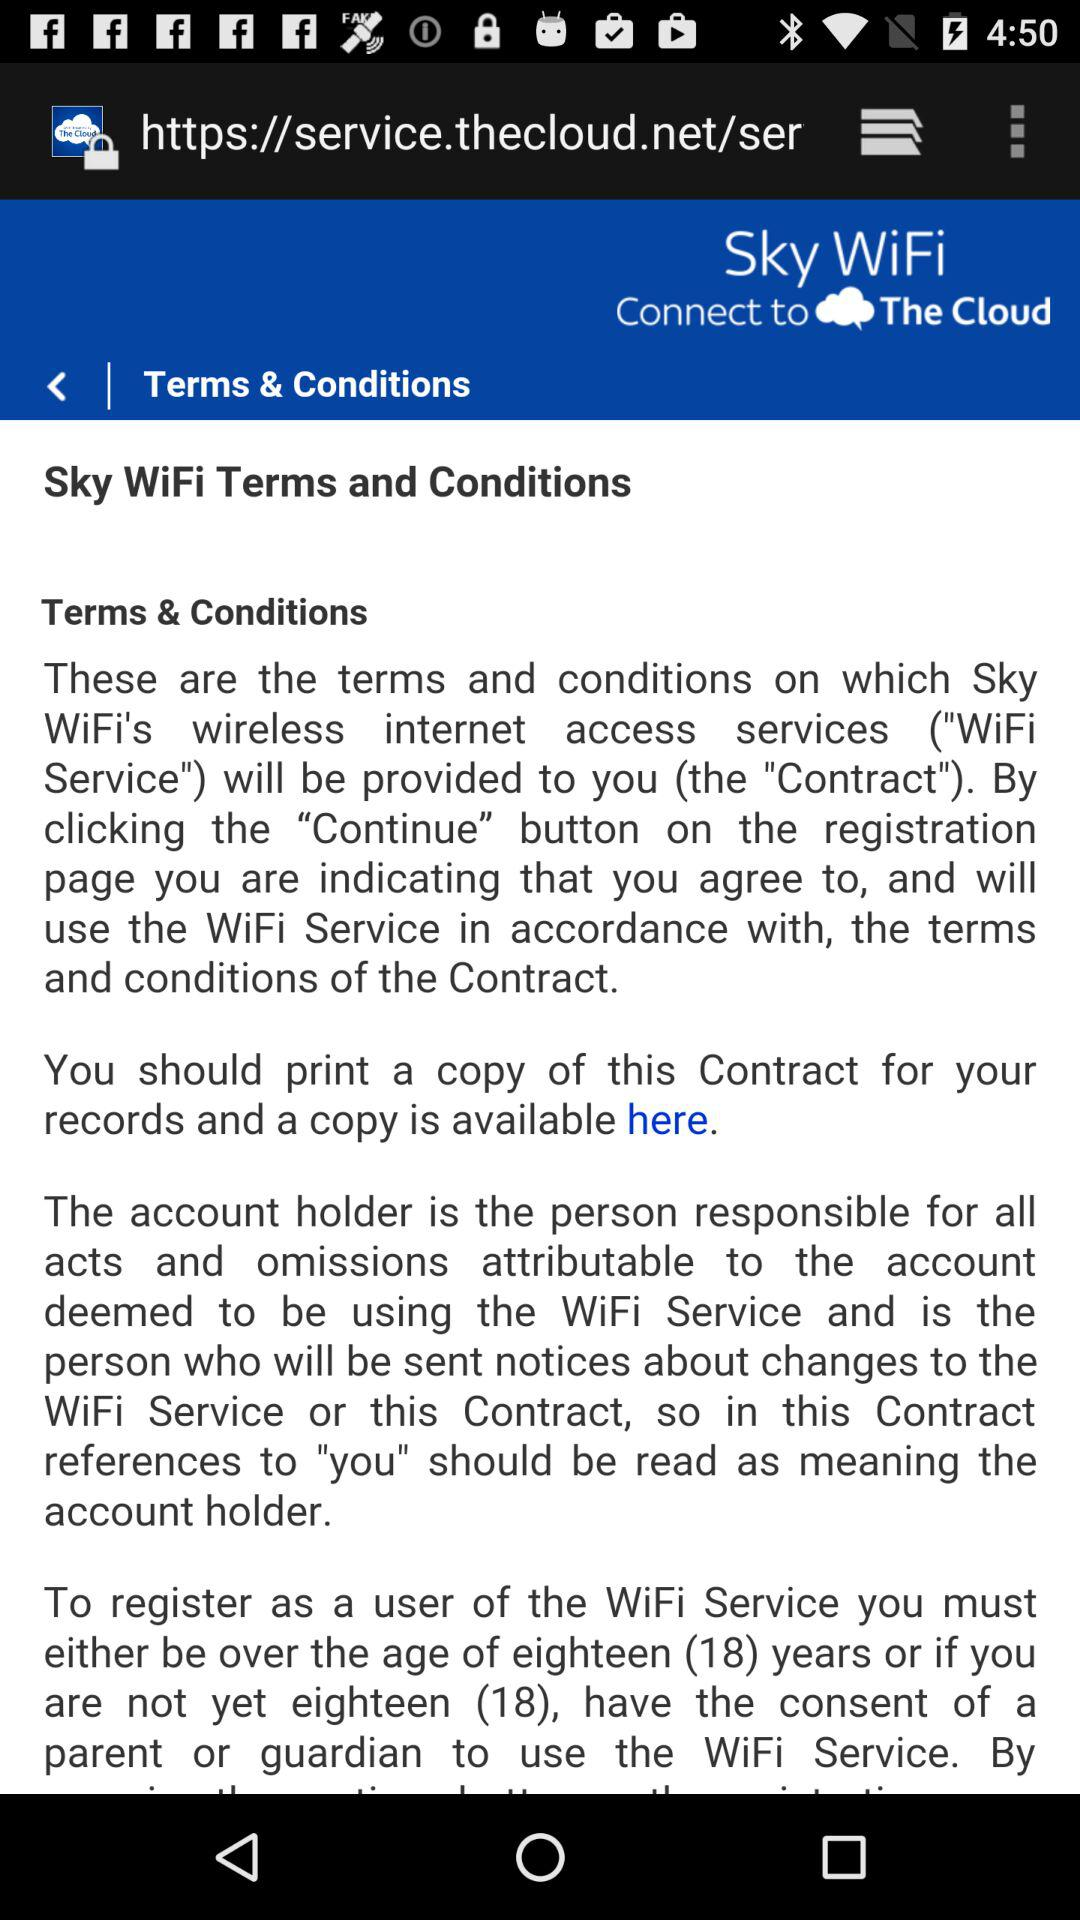What is the minimum age to register for the WiFi service? The minimum age to register for the WiFi service is eighteen. 